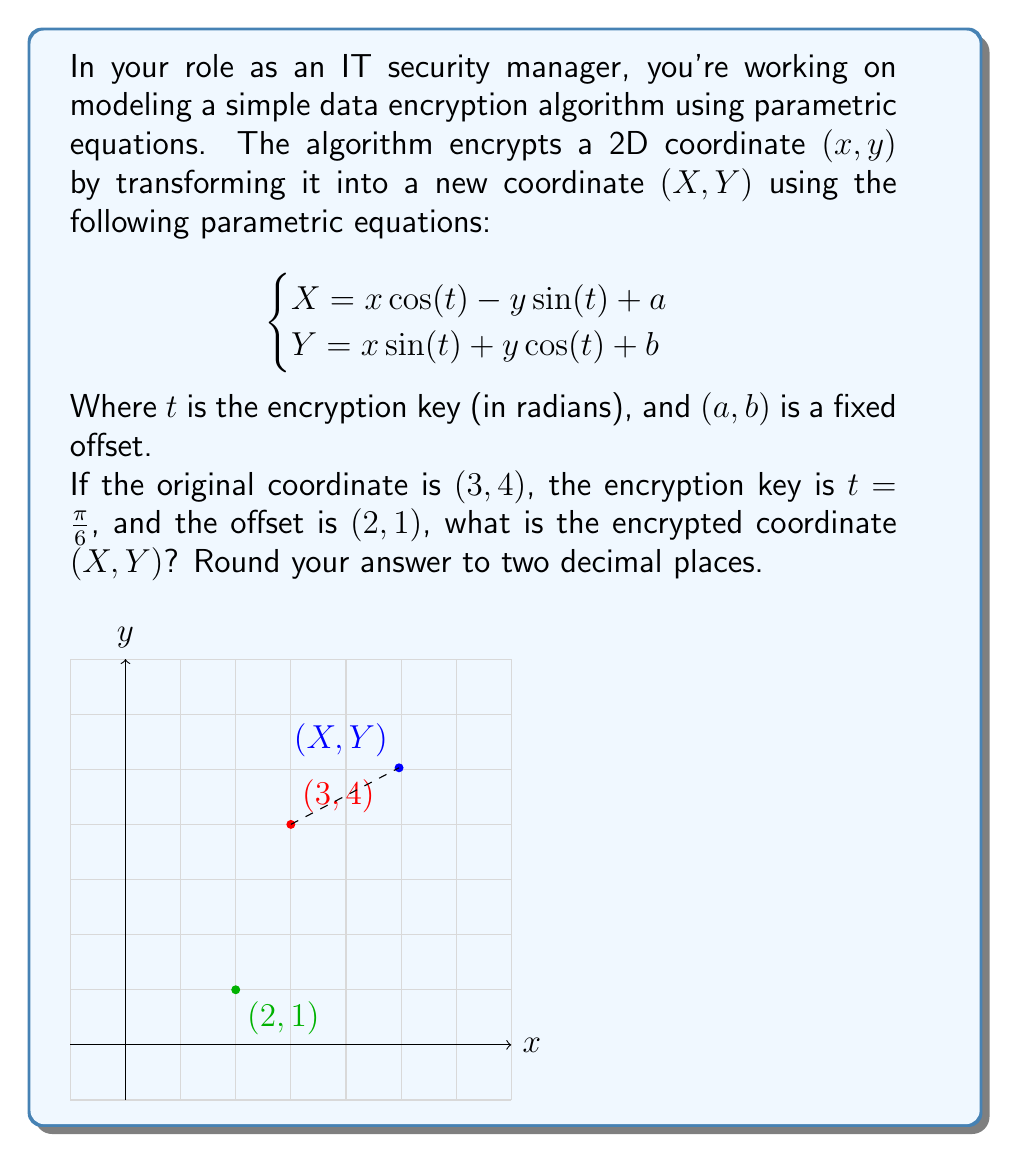Help me with this question. Let's solve this step-by-step:

1) We're given the parametric equations:
   $$\begin{cases}
   X = x \cos(t) - y \sin(t) + a \\
   Y = x \sin(t) + y \cos(t) + b
   \end{cases}$$

2) We know:
   - Original coordinate: $(x,y) = (3,4)$
   - Encryption key: $t = \frac{\pi}{6}$
   - Offset: $(a,b) = (2,1)$

3) Let's calculate $\cos(\frac{\pi}{6})$ and $\sin(\frac{\pi}{6})$:
   $\cos(\frac{\pi}{6}) = \frac{\sqrt{3}}{2} \approx 0.866$
   $\sin(\frac{\pi}{6}) = \frac{1}{2} = 0.5$

4) Now, let's substitute these values into our equations:

   For X:
   $$\begin{align}
   X &= x \cos(t) - y \sin(t) + a \\
   &= 3 \cdot \frac{\sqrt{3}}{2} - 4 \cdot \frac{1}{2} + 2 \\
   &= \frac{3\sqrt{3}}{2} - 2 + 2 \\
   &= \frac{3\sqrt{3}}{2} \approx 2.60
   \end{align}$$

   For Y:
   $$\begin{align}
   Y &= x \sin(t) + y \cos(t) + b \\
   &= 3 \cdot \frac{1}{2} + 4 \cdot \frac{\sqrt{3}}{2} + 1 \\
   &= \frac{3}{2} + 2\sqrt{3} + 1 \\
   &= \frac{5}{2} + 2\sqrt{3} \approx 5.96
   \end{align}$$

5) Rounding to two decimal places, we get:
   $X \approx 2.60$
   $Y \approx 5.96$

Therefore, the encrypted coordinate is approximately $(2.60, 5.96)$.
Answer: $(2.60, 5.96)$ 